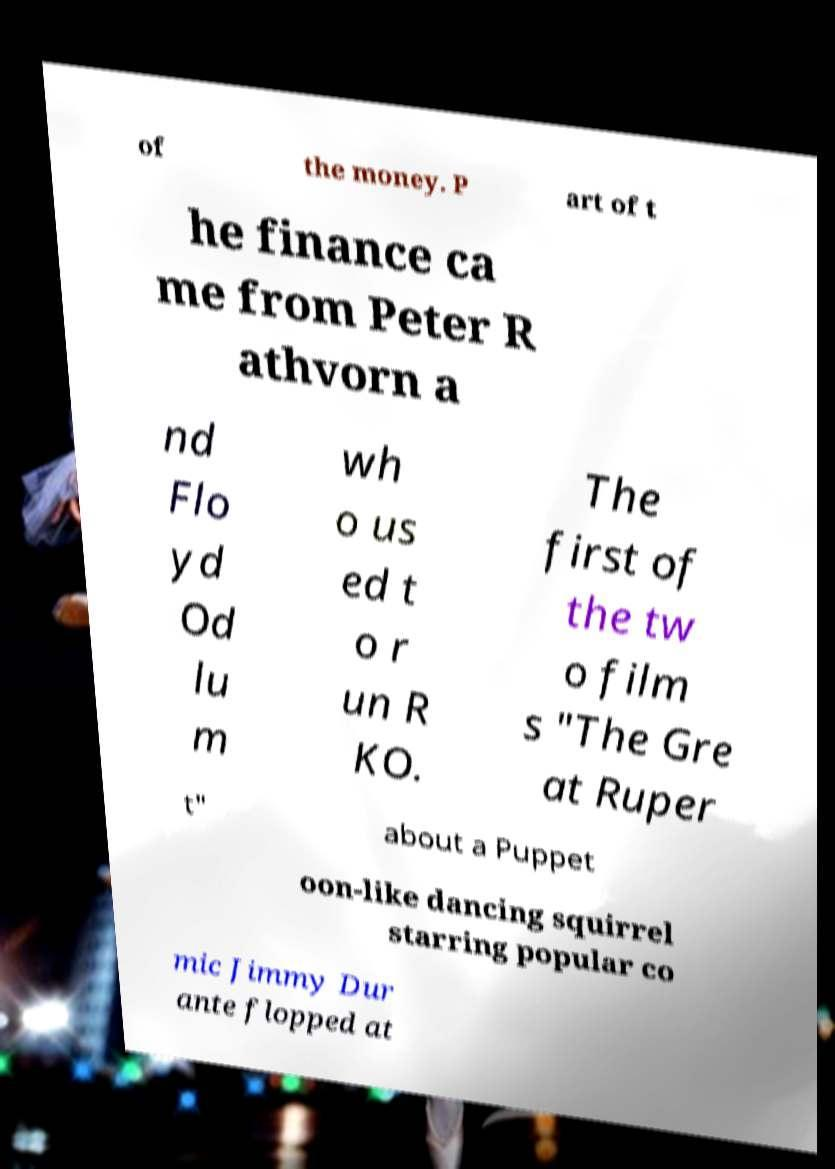Can you read and provide the text displayed in the image?This photo seems to have some interesting text. Can you extract and type it out for me? of the money. P art of t he finance ca me from Peter R athvorn a nd Flo yd Od lu m wh o us ed t o r un R KO. The first of the tw o film s "The Gre at Ruper t" about a Puppet oon-like dancing squirrel starring popular co mic Jimmy Dur ante flopped at 